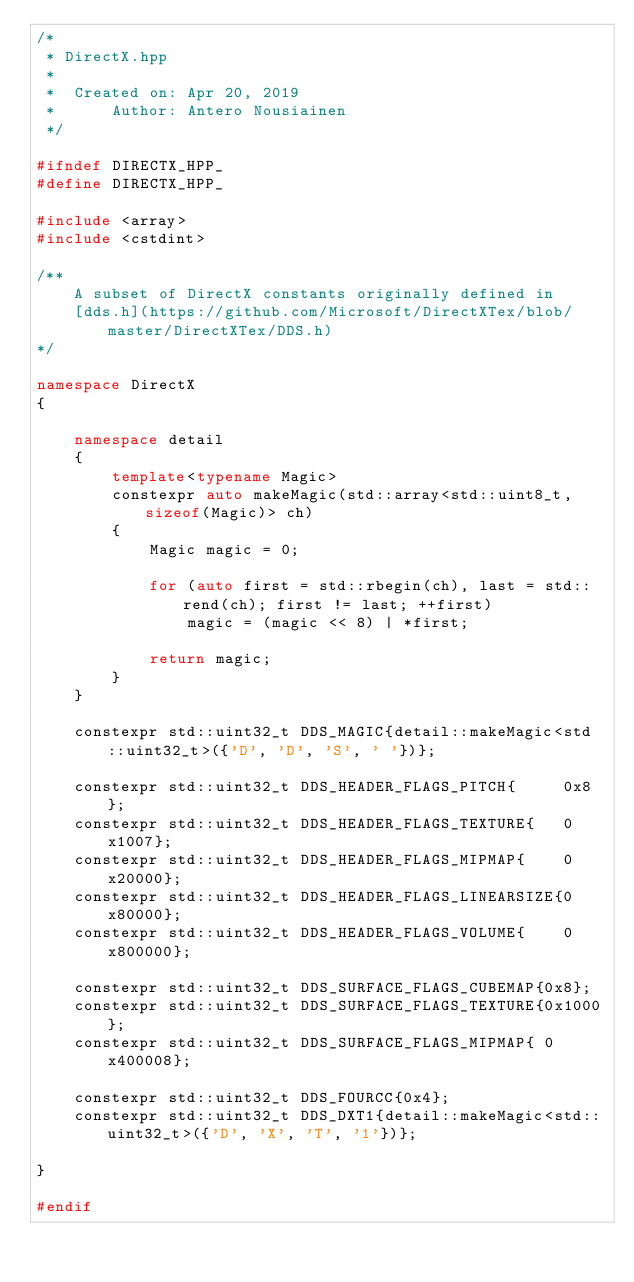Convert code to text. <code><loc_0><loc_0><loc_500><loc_500><_C++_>/*
 * DirectX.hpp
 *
 *  Created on: Apr 20, 2019
 *      Author: Antero Nousiainen
 */

#ifndef DIRECTX_HPP_
#define DIRECTX_HPP_

#include <array>
#include <cstdint>

/**
    A subset of DirectX constants originally defined in
    [dds.h](https://github.com/Microsoft/DirectXTex/blob/master/DirectXTex/DDS.h)
*/

namespace DirectX
{

    namespace detail
    {
        template<typename Magic>
        constexpr auto makeMagic(std::array<std::uint8_t, sizeof(Magic)> ch)
        {
            Magic magic = 0;

            for (auto first = std::rbegin(ch), last = std::rend(ch); first != last; ++first)
                magic = (magic << 8) | *first;

            return magic;
        }
    }

    constexpr std::uint32_t DDS_MAGIC{detail::makeMagic<std::uint32_t>({'D', 'D', 'S', ' '})};

    constexpr std::uint32_t DDS_HEADER_FLAGS_PITCH{     0x8};
    constexpr std::uint32_t DDS_HEADER_FLAGS_TEXTURE{   0x1007};
    constexpr std::uint32_t DDS_HEADER_FLAGS_MIPMAP{    0x20000};
    constexpr std::uint32_t DDS_HEADER_FLAGS_LINEARSIZE{0x80000};
    constexpr std::uint32_t DDS_HEADER_FLAGS_VOLUME{    0x800000};

    constexpr std::uint32_t DDS_SURFACE_FLAGS_CUBEMAP{0x8};
    constexpr std::uint32_t DDS_SURFACE_FLAGS_TEXTURE{0x1000};
    constexpr std::uint32_t DDS_SURFACE_FLAGS_MIPMAP{ 0x400008};

    constexpr std::uint32_t DDS_FOURCC{0x4};
    constexpr std::uint32_t DDS_DXT1{detail::makeMagic<std::uint32_t>({'D', 'X', 'T', '1'})};

}

#endif
</code> 